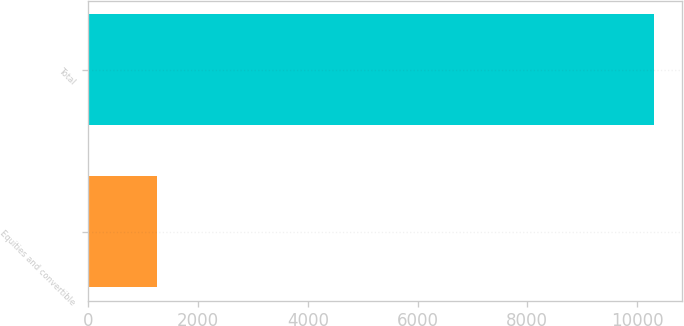<chart> <loc_0><loc_0><loc_500><loc_500><bar_chart><fcel>Equities and convertible<fcel>Total<nl><fcel>1248<fcel>10307<nl></chart> 